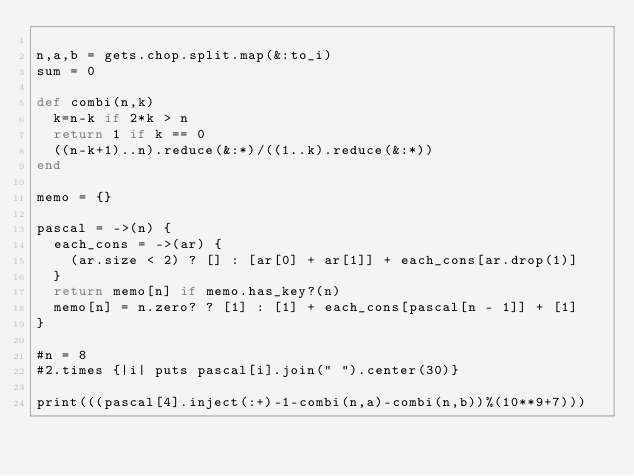Convert code to text. <code><loc_0><loc_0><loc_500><loc_500><_Ruby_>
n,a,b = gets.chop.split.map(&:to_i)
sum = 0

def combi(n,k)
  k=n-k if 2*k > n
  return 1 if k == 0
  ((n-k+1)..n).reduce(&:*)/((1..k).reduce(&:*))
end

memo = {}

pascal = ->(n) {
  each_cons = ->(ar) {
    (ar.size < 2) ? [] : [ar[0] + ar[1]] + each_cons[ar.drop(1)]
  }
  return memo[n] if memo.has_key?(n)
  memo[n] = n.zero? ? [1] : [1] + each_cons[pascal[n - 1]] + [1]
}

#n = 8
#2.times {|i| puts pascal[i].join(" ").center(30)}

print(((pascal[4].inject(:+)-1-combi(n,a)-combi(n,b))%(10**9+7)))



</code> 